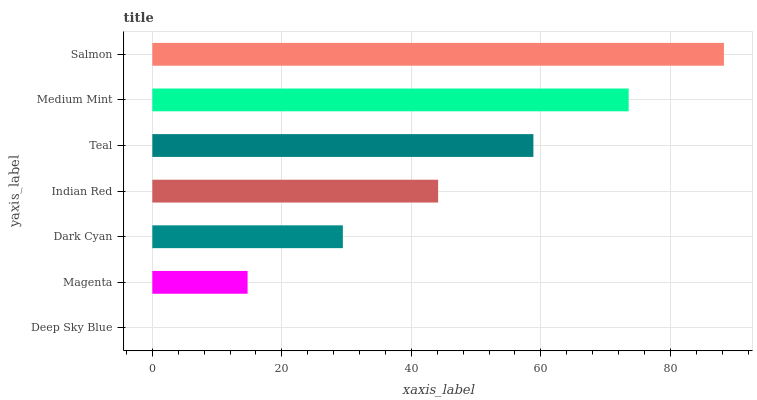Is Deep Sky Blue the minimum?
Answer yes or no. Yes. Is Salmon the maximum?
Answer yes or no. Yes. Is Magenta the minimum?
Answer yes or no. No. Is Magenta the maximum?
Answer yes or no. No. Is Magenta greater than Deep Sky Blue?
Answer yes or no. Yes. Is Deep Sky Blue less than Magenta?
Answer yes or no. Yes. Is Deep Sky Blue greater than Magenta?
Answer yes or no. No. Is Magenta less than Deep Sky Blue?
Answer yes or no. No. Is Indian Red the high median?
Answer yes or no. Yes. Is Indian Red the low median?
Answer yes or no. Yes. Is Dark Cyan the high median?
Answer yes or no. No. Is Medium Mint the low median?
Answer yes or no. No. 